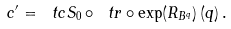Convert formula to latex. <formula><loc_0><loc_0><loc_500><loc_500>c ^ { \prime } = \ t c S _ { 0 } \circ \ t r \circ \exp ( R _ { B ^ { q } } ) \, ( q ) \, .</formula> 